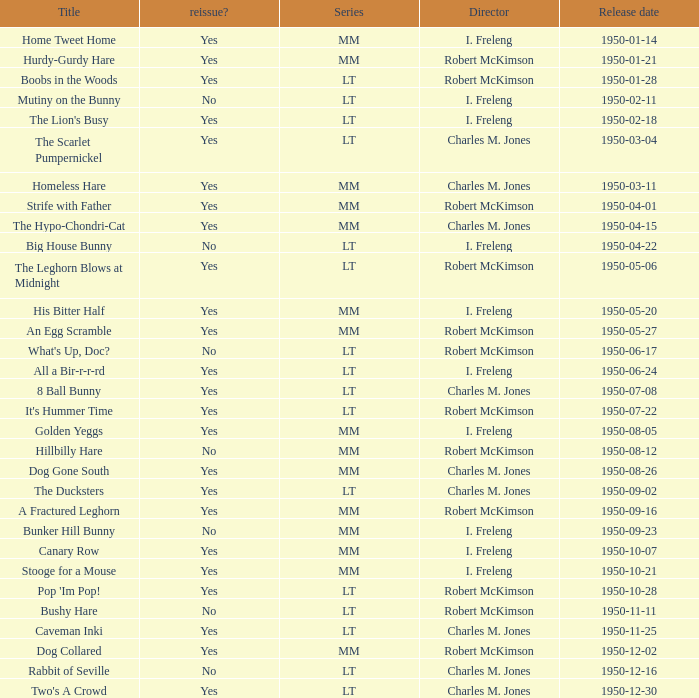Help me parse the entirety of this table. {'header': ['Title', 'reissue?', 'Series', 'Director', 'Release date'], 'rows': [['Home Tweet Home', 'Yes', 'MM', 'I. Freleng', '1950-01-14'], ['Hurdy-Gurdy Hare', 'Yes', 'MM', 'Robert McKimson', '1950-01-21'], ['Boobs in the Woods', 'Yes', 'LT', 'Robert McKimson', '1950-01-28'], ['Mutiny on the Bunny', 'No', 'LT', 'I. Freleng', '1950-02-11'], ["The Lion's Busy", 'Yes', 'LT', 'I. Freleng', '1950-02-18'], ['The Scarlet Pumpernickel', 'Yes', 'LT', 'Charles M. Jones', '1950-03-04'], ['Homeless Hare', 'Yes', 'MM', 'Charles M. Jones', '1950-03-11'], ['Strife with Father', 'Yes', 'MM', 'Robert McKimson', '1950-04-01'], ['The Hypo-Chondri-Cat', 'Yes', 'MM', 'Charles M. Jones', '1950-04-15'], ['Big House Bunny', 'No', 'LT', 'I. Freleng', '1950-04-22'], ['The Leghorn Blows at Midnight', 'Yes', 'LT', 'Robert McKimson', '1950-05-06'], ['His Bitter Half', 'Yes', 'MM', 'I. Freleng', '1950-05-20'], ['An Egg Scramble', 'Yes', 'MM', 'Robert McKimson', '1950-05-27'], ["What's Up, Doc?", 'No', 'LT', 'Robert McKimson', '1950-06-17'], ['All a Bir-r-r-rd', 'Yes', 'LT', 'I. Freleng', '1950-06-24'], ['8 Ball Bunny', 'Yes', 'LT', 'Charles M. Jones', '1950-07-08'], ["It's Hummer Time", 'Yes', 'LT', 'Robert McKimson', '1950-07-22'], ['Golden Yeggs', 'Yes', 'MM', 'I. Freleng', '1950-08-05'], ['Hillbilly Hare', 'No', 'MM', 'Robert McKimson', '1950-08-12'], ['Dog Gone South', 'Yes', 'MM', 'Charles M. Jones', '1950-08-26'], ['The Ducksters', 'Yes', 'LT', 'Charles M. Jones', '1950-09-02'], ['A Fractured Leghorn', 'Yes', 'MM', 'Robert McKimson', '1950-09-16'], ['Bunker Hill Bunny', 'No', 'MM', 'I. Freleng', '1950-09-23'], ['Canary Row', 'Yes', 'MM', 'I. Freleng', '1950-10-07'], ['Stooge for a Mouse', 'Yes', 'MM', 'I. Freleng', '1950-10-21'], ["Pop 'Im Pop!", 'Yes', 'LT', 'Robert McKimson', '1950-10-28'], ['Bushy Hare', 'No', 'LT', 'Robert McKimson', '1950-11-11'], ['Caveman Inki', 'Yes', 'LT', 'Charles M. Jones', '1950-11-25'], ['Dog Collared', 'Yes', 'MM', 'Robert McKimson', '1950-12-02'], ['Rabbit of Seville', 'No', 'LT', 'Charles M. Jones', '1950-12-16'], ["Two's A Crowd", 'Yes', 'LT', 'Charles M. Jones', '1950-12-30']]} Who directed An Egg Scramble? Robert McKimson. 